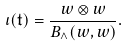<formula> <loc_0><loc_0><loc_500><loc_500>\iota ( \mathfrak t ) = \frac { w \otimes w } { B _ { \wedge } ( w , w ) } .</formula> 